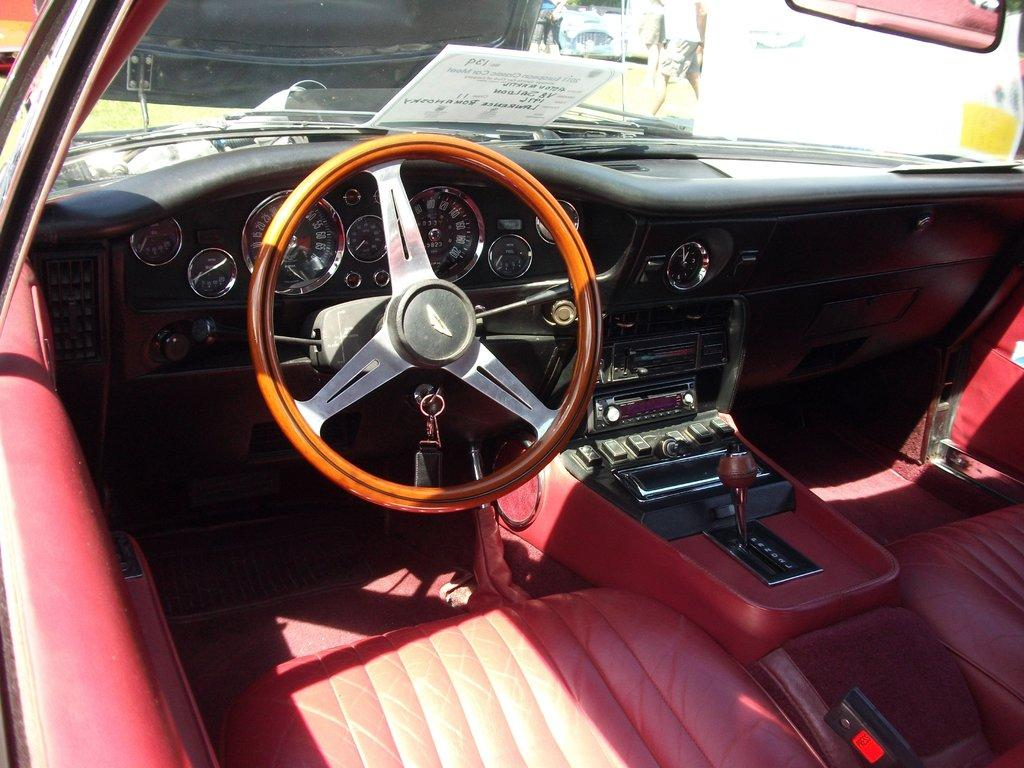What type of vehicle is shown in the image? There is an inner view of a car in the image. Can you describe the person in the image? There is a person on the ground in the image. What type of notebook is the zebra holding in the image? There is no notebook or zebra present in the image. 